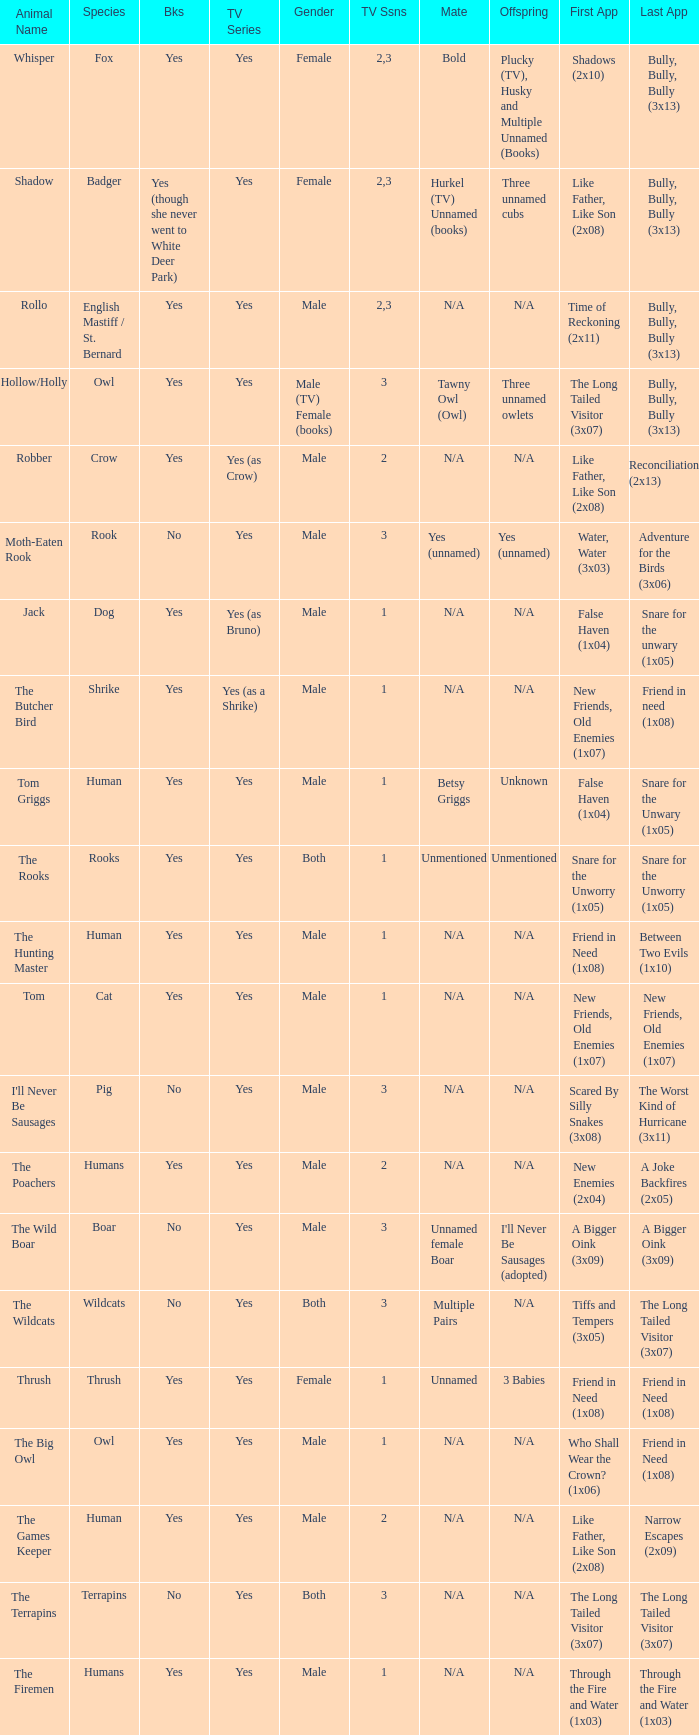Beyond season 1, who is the partner for hollow/holly in the episode titled "last appearance of bully, bully, bully (3x13)?" Tawny Owl (Owl). 